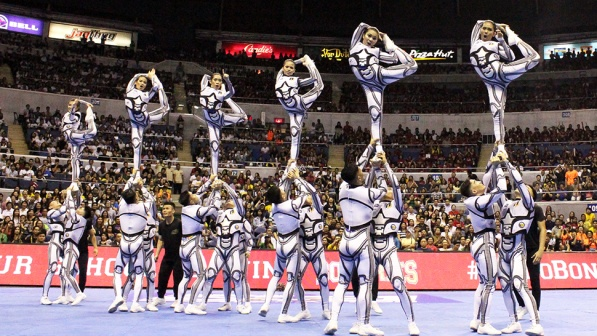What is this photo about'? This photo captures an impressive moment at a sporting event where a cheerleading squad is performing a remarkable stunt. The cheerleaders are dressed in matching white and blue uniforms and are forming a series of human structures. Each structure is composed of a base of cheerleaders who are supporting their teammates, who are performing high leg holds while standing on their shoulders. In the background, you can see a large crowd of spectators, adding to the excitement and energy of the scene. The focal point of the image is the precision, balance, and teamwork displayed by the cheerleaders, creating a captivating and energetic atmosphere. 